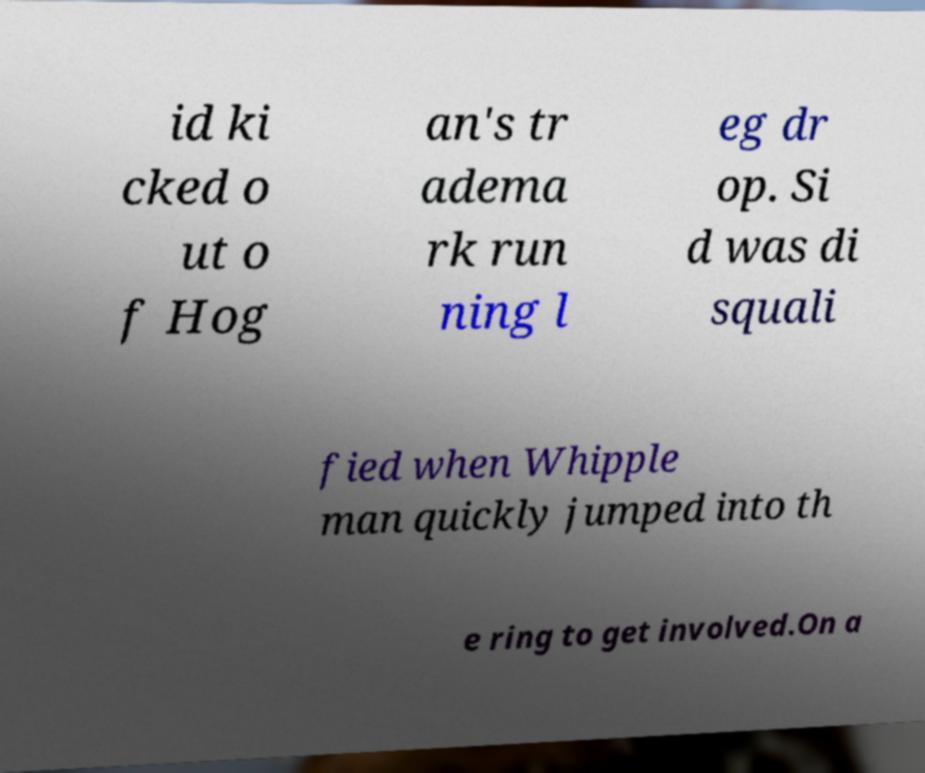Please identify and transcribe the text found in this image. id ki cked o ut o f Hog an's tr adema rk run ning l eg dr op. Si d was di squali fied when Whipple man quickly jumped into th e ring to get involved.On a 